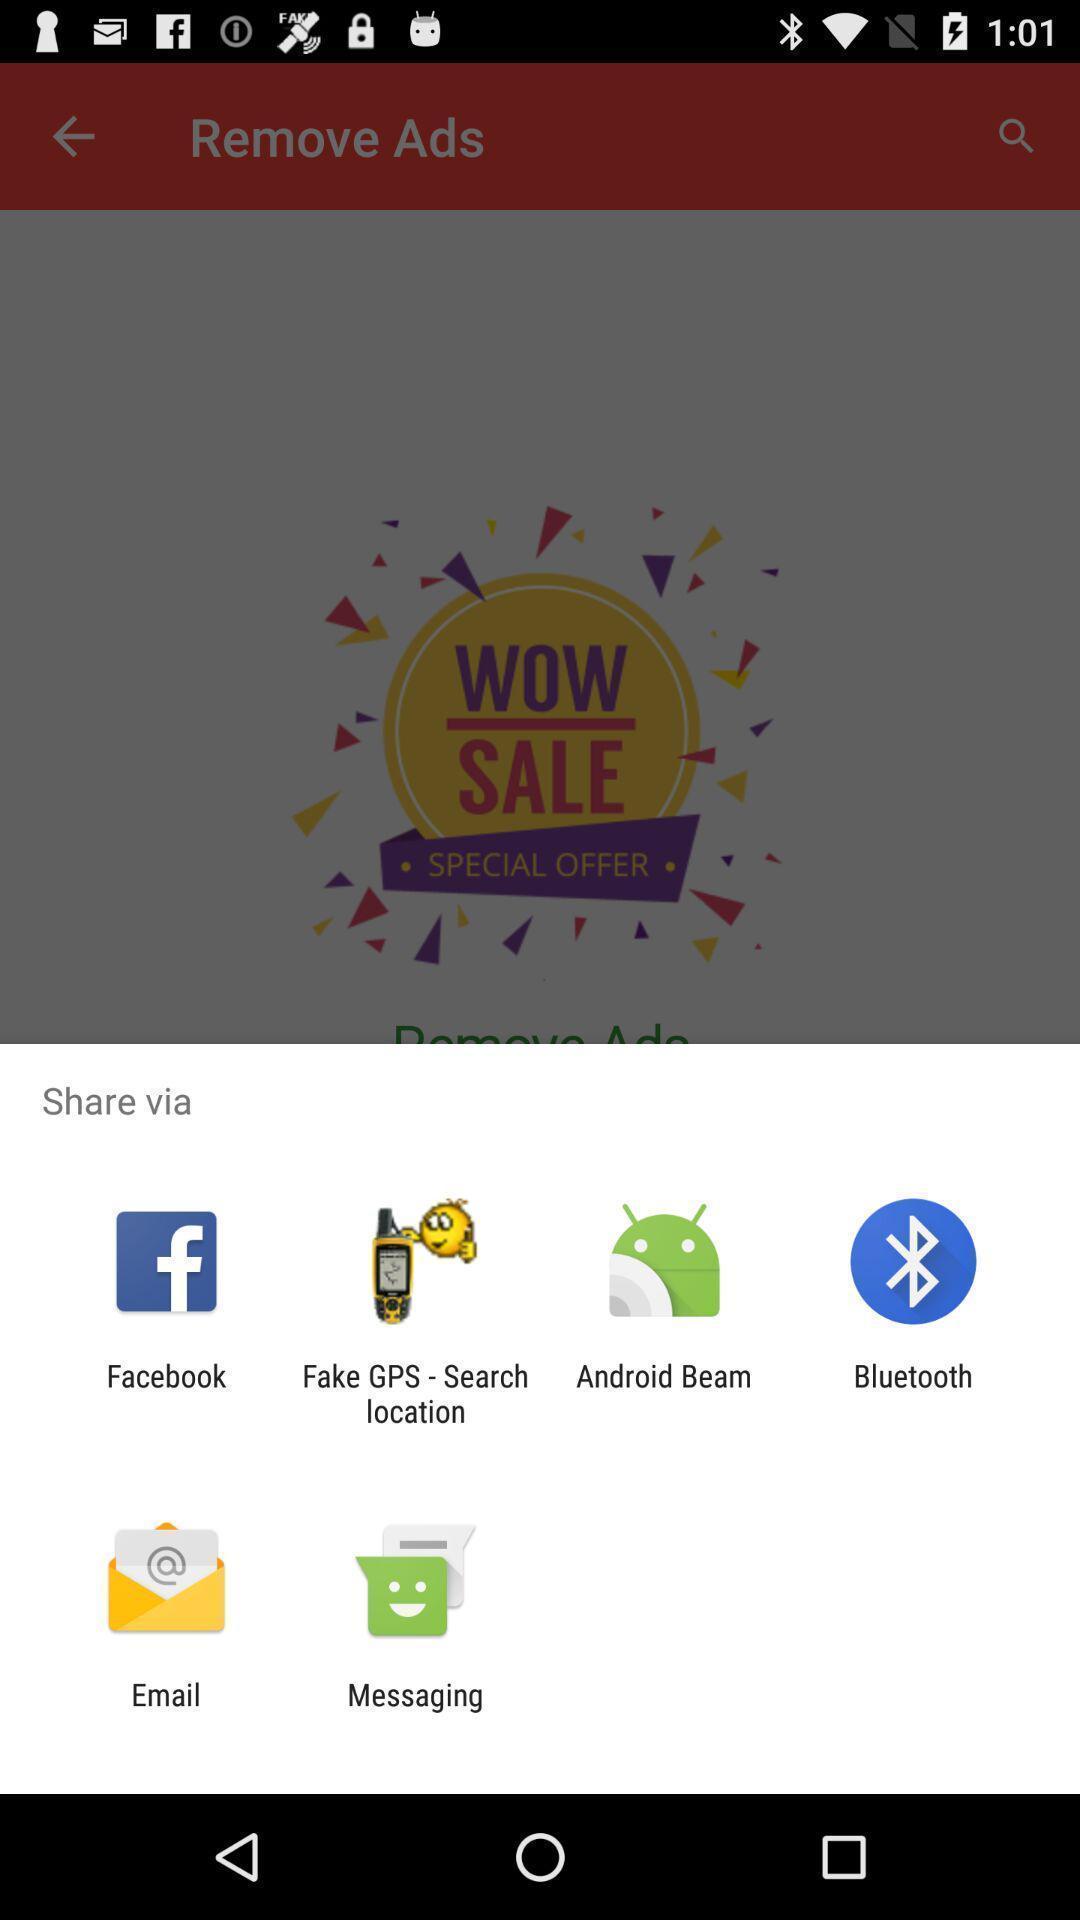Give me a summary of this screen capture. Share information via different apps. 